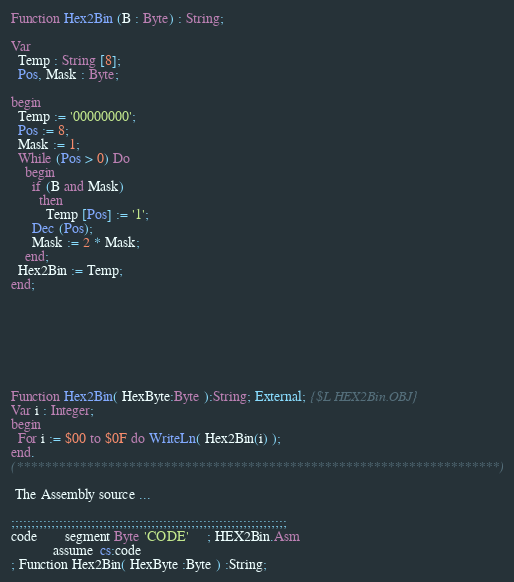Convert code to text. <code><loc_0><loc_0><loc_500><loc_500><_Pascal_>Function Hex2Bin (B : Byte) : String;

Var
  Temp : String [8];
  Pos, Mask : Byte;

begin
  Temp := '00000000';
  Pos := 8;
  Mask := 1;
  While (Pos > 0) Do
    begin
      if (B and Mask)
        then
          Temp [Pos] := '1';
      Dec (Pos);
      Mask := 2 * Mask;
    end;
  Hex2Bin := Temp;
end;







Function Hex2Bin( HexByte:Byte ):String; External; {$L HEX2Bin.OBJ}
Var i : Integer;
begin
  For i := $00 to $0F do WriteLn( Hex2Bin(i) );
end.
(*********************************************************************)

 The Assembly source ...

;;;;;;;;;;;;;;;;;;;;;;;;;;;;;;;;;;;;;;;;;;;;;;;;;;;;;;;;;;;;;;;;;;;;;
code        segment Byte 'CODE'     ; HEX2Bin.Asm
            assume  cs:code
; Function Hex2Bin( HexByte :Byte ) :String;</code> 